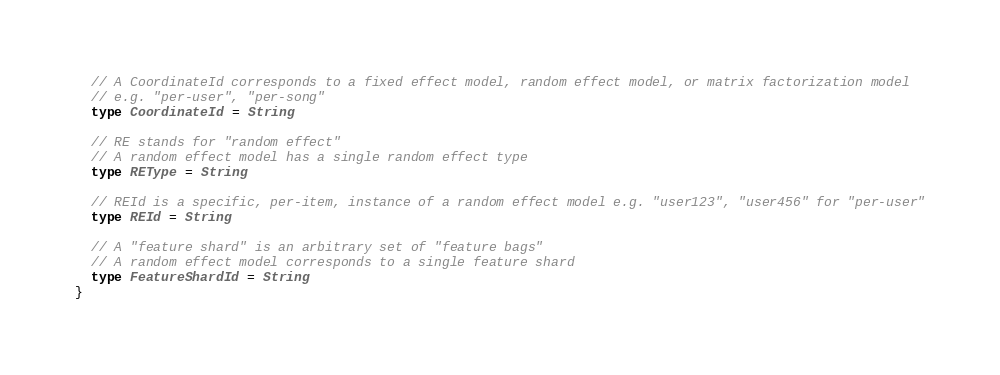Convert code to text. <code><loc_0><loc_0><loc_500><loc_500><_Scala_>
  // A CoordinateId corresponds to a fixed effect model, random effect model, or matrix factorization model
  // e.g. "per-user", "per-song"
  type CoordinateId = String

  // RE stands for "random effect"
  // A random effect model has a single random effect type
  type REType = String

  // REId is a specific, per-item, instance of a random effect model e.g. "user123", "user456" for "per-user"
  type REId = String

  // A "feature shard" is an arbitrary set of "feature bags"
  // A random effect model corresponds to a single feature shard
  type FeatureShardId = String
}
</code> 